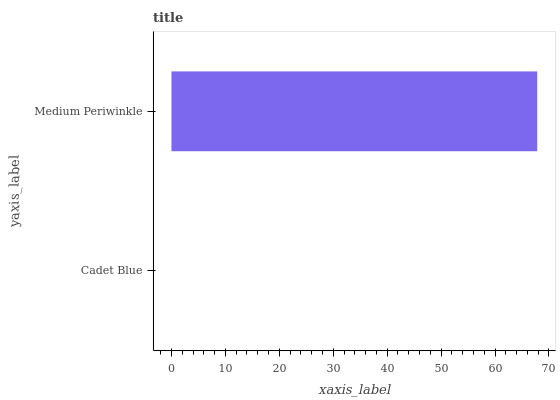Is Cadet Blue the minimum?
Answer yes or no. Yes. Is Medium Periwinkle the maximum?
Answer yes or no. Yes. Is Medium Periwinkle the minimum?
Answer yes or no. No. Is Medium Periwinkle greater than Cadet Blue?
Answer yes or no. Yes. Is Cadet Blue less than Medium Periwinkle?
Answer yes or no. Yes. Is Cadet Blue greater than Medium Periwinkle?
Answer yes or no. No. Is Medium Periwinkle less than Cadet Blue?
Answer yes or no. No. Is Medium Periwinkle the high median?
Answer yes or no. Yes. Is Cadet Blue the low median?
Answer yes or no. Yes. Is Cadet Blue the high median?
Answer yes or no. No. Is Medium Periwinkle the low median?
Answer yes or no. No. 